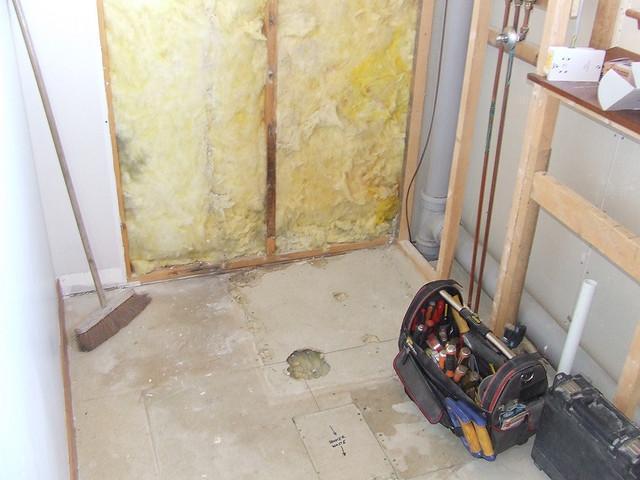How many suitcases are in the photo?
Give a very brief answer. 2. 